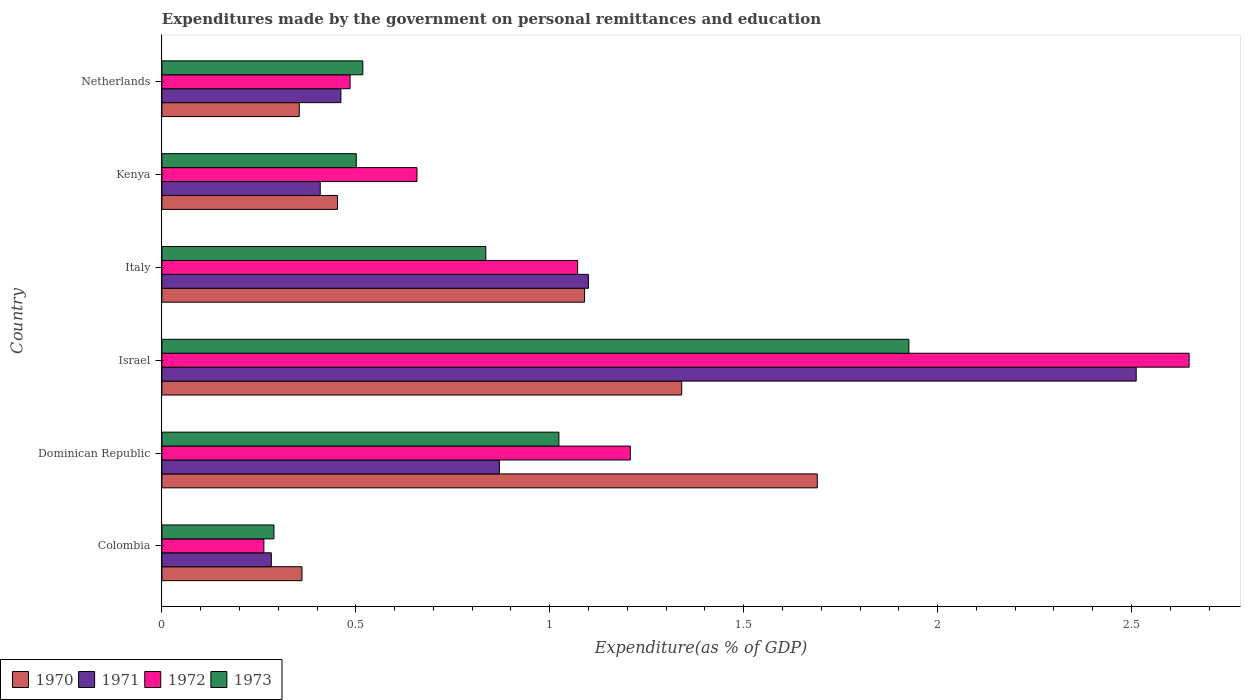How many different coloured bars are there?
Make the answer very short. 4. Are the number of bars per tick equal to the number of legend labels?
Keep it short and to the point. Yes. Are the number of bars on each tick of the Y-axis equal?
Provide a succinct answer. Yes. What is the label of the 2nd group of bars from the top?
Keep it short and to the point. Kenya. What is the expenditures made by the government on personal remittances and education in 1973 in Dominican Republic?
Give a very brief answer. 1.02. Across all countries, what is the maximum expenditures made by the government on personal remittances and education in 1972?
Offer a terse response. 2.65. Across all countries, what is the minimum expenditures made by the government on personal remittances and education in 1970?
Your answer should be compact. 0.35. In which country was the expenditures made by the government on personal remittances and education in 1972 minimum?
Provide a succinct answer. Colombia. What is the total expenditures made by the government on personal remittances and education in 1971 in the graph?
Ensure brevity in your answer.  5.63. What is the difference between the expenditures made by the government on personal remittances and education in 1971 in Dominican Republic and that in Netherlands?
Give a very brief answer. 0.41. What is the difference between the expenditures made by the government on personal remittances and education in 1972 in Dominican Republic and the expenditures made by the government on personal remittances and education in 1971 in Italy?
Ensure brevity in your answer.  0.11. What is the average expenditures made by the government on personal remittances and education in 1972 per country?
Provide a short and direct response. 1.06. What is the difference between the expenditures made by the government on personal remittances and education in 1973 and expenditures made by the government on personal remittances and education in 1970 in Israel?
Provide a succinct answer. 0.59. What is the ratio of the expenditures made by the government on personal remittances and education in 1973 in Dominican Republic to that in Kenya?
Offer a terse response. 2.04. Is the expenditures made by the government on personal remittances and education in 1971 in Colombia less than that in Italy?
Your response must be concise. Yes. Is the difference between the expenditures made by the government on personal remittances and education in 1973 in Italy and Netherlands greater than the difference between the expenditures made by the government on personal remittances and education in 1970 in Italy and Netherlands?
Offer a terse response. No. What is the difference between the highest and the second highest expenditures made by the government on personal remittances and education in 1971?
Your answer should be compact. 1.41. What is the difference between the highest and the lowest expenditures made by the government on personal remittances and education in 1971?
Your answer should be very brief. 2.23. In how many countries, is the expenditures made by the government on personal remittances and education in 1970 greater than the average expenditures made by the government on personal remittances and education in 1970 taken over all countries?
Offer a terse response. 3. What does the 3rd bar from the top in Colombia represents?
Offer a very short reply. 1971. What does the 1st bar from the bottom in Italy represents?
Ensure brevity in your answer.  1970. Is it the case that in every country, the sum of the expenditures made by the government on personal remittances and education in 1970 and expenditures made by the government on personal remittances and education in 1972 is greater than the expenditures made by the government on personal remittances and education in 1971?
Your answer should be compact. Yes. How many bars are there?
Keep it short and to the point. 24. Are all the bars in the graph horizontal?
Ensure brevity in your answer.  Yes. Are the values on the major ticks of X-axis written in scientific E-notation?
Your answer should be very brief. No. Does the graph contain grids?
Your answer should be very brief. No. Where does the legend appear in the graph?
Ensure brevity in your answer.  Bottom left. How many legend labels are there?
Make the answer very short. 4. How are the legend labels stacked?
Your answer should be very brief. Horizontal. What is the title of the graph?
Give a very brief answer. Expenditures made by the government on personal remittances and education. Does "1978" appear as one of the legend labels in the graph?
Ensure brevity in your answer.  No. What is the label or title of the X-axis?
Provide a succinct answer. Expenditure(as % of GDP). What is the Expenditure(as % of GDP) in 1970 in Colombia?
Keep it short and to the point. 0.36. What is the Expenditure(as % of GDP) of 1971 in Colombia?
Your answer should be compact. 0.28. What is the Expenditure(as % of GDP) in 1972 in Colombia?
Give a very brief answer. 0.26. What is the Expenditure(as % of GDP) of 1973 in Colombia?
Keep it short and to the point. 0.29. What is the Expenditure(as % of GDP) in 1970 in Dominican Republic?
Provide a short and direct response. 1.69. What is the Expenditure(as % of GDP) of 1971 in Dominican Republic?
Ensure brevity in your answer.  0.87. What is the Expenditure(as % of GDP) of 1972 in Dominican Republic?
Your response must be concise. 1.21. What is the Expenditure(as % of GDP) of 1973 in Dominican Republic?
Your response must be concise. 1.02. What is the Expenditure(as % of GDP) in 1970 in Israel?
Keep it short and to the point. 1.34. What is the Expenditure(as % of GDP) in 1971 in Israel?
Ensure brevity in your answer.  2.51. What is the Expenditure(as % of GDP) in 1972 in Israel?
Provide a succinct answer. 2.65. What is the Expenditure(as % of GDP) of 1973 in Israel?
Give a very brief answer. 1.93. What is the Expenditure(as % of GDP) of 1970 in Italy?
Give a very brief answer. 1.09. What is the Expenditure(as % of GDP) in 1971 in Italy?
Make the answer very short. 1.1. What is the Expenditure(as % of GDP) in 1972 in Italy?
Offer a terse response. 1.07. What is the Expenditure(as % of GDP) of 1973 in Italy?
Provide a succinct answer. 0.84. What is the Expenditure(as % of GDP) in 1970 in Kenya?
Provide a succinct answer. 0.45. What is the Expenditure(as % of GDP) in 1971 in Kenya?
Keep it short and to the point. 0.41. What is the Expenditure(as % of GDP) in 1972 in Kenya?
Provide a succinct answer. 0.66. What is the Expenditure(as % of GDP) in 1973 in Kenya?
Give a very brief answer. 0.5. What is the Expenditure(as % of GDP) of 1970 in Netherlands?
Keep it short and to the point. 0.35. What is the Expenditure(as % of GDP) in 1971 in Netherlands?
Give a very brief answer. 0.46. What is the Expenditure(as % of GDP) of 1972 in Netherlands?
Your answer should be compact. 0.49. What is the Expenditure(as % of GDP) of 1973 in Netherlands?
Your response must be concise. 0.52. Across all countries, what is the maximum Expenditure(as % of GDP) in 1970?
Your answer should be compact. 1.69. Across all countries, what is the maximum Expenditure(as % of GDP) in 1971?
Provide a succinct answer. 2.51. Across all countries, what is the maximum Expenditure(as % of GDP) of 1972?
Provide a short and direct response. 2.65. Across all countries, what is the maximum Expenditure(as % of GDP) of 1973?
Your response must be concise. 1.93. Across all countries, what is the minimum Expenditure(as % of GDP) of 1970?
Ensure brevity in your answer.  0.35. Across all countries, what is the minimum Expenditure(as % of GDP) in 1971?
Offer a very short reply. 0.28. Across all countries, what is the minimum Expenditure(as % of GDP) in 1972?
Give a very brief answer. 0.26. Across all countries, what is the minimum Expenditure(as % of GDP) of 1973?
Keep it short and to the point. 0.29. What is the total Expenditure(as % of GDP) in 1970 in the graph?
Provide a succinct answer. 5.29. What is the total Expenditure(as % of GDP) in 1971 in the graph?
Offer a terse response. 5.63. What is the total Expenditure(as % of GDP) in 1972 in the graph?
Your response must be concise. 6.33. What is the total Expenditure(as % of GDP) in 1973 in the graph?
Give a very brief answer. 5.09. What is the difference between the Expenditure(as % of GDP) in 1970 in Colombia and that in Dominican Republic?
Your answer should be very brief. -1.33. What is the difference between the Expenditure(as % of GDP) in 1971 in Colombia and that in Dominican Republic?
Give a very brief answer. -0.59. What is the difference between the Expenditure(as % of GDP) of 1972 in Colombia and that in Dominican Republic?
Offer a terse response. -0.94. What is the difference between the Expenditure(as % of GDP) of 1973 in Colombia and that in Dominican Republic?
Your answer should be compact. -0.73. What is the difference between the Expenditure(as % of GDP) of 1970 in Colombia and that in Israel?
Your response must be concise. -0.98. What is the difference between the Expenditure(as % of GDP) in 1971 in Colombia and that in Israel?
Provide a succinct answer. -2.23. What is the difference between the Expenditure(as % of GDP) in 1972 in Colombia and that in Israel?
Your answer should be compact. -2.39. What is the difference between the Expenditure(as % of GDP) in 1973 in Colombia and that in Israel?
Your answer should be very brief. -1.64. What is the difference between the Expenditure(as % of GDP) of 1970 in Colombia and that in Italy?
Offer a terse response. -0.73. What is the difference between the Expenditure(as % of GDP) in 1971 in Colombia and that in Italy?
Make the answer very short. -0.82. What is the difference between the Expenditure(as % of GDP) of 1972 in Colombia and that in Italy?
Offer a very short reply. -0.81. What is the difference between the Expenditure(as % of GDP) of 1973 in Colombia and that in Italy?
Your answer should be very brief. -0.55. What is the difference between the Expenditure(as % of GDP) of 1970 in Colombia and that in Kenya?
Keep it short and to the point. -0.09. What is the difference between the Expenditure(as % of GDP) in 1971 in Colombia and that in Kenya?
Ensure brevity in your answer.  -0.13. What is the difference between the Expenditure(as % of GDP) of 1972 in Colombia and that in Kenya?
Offer a terse response. -0.39. What is the difference between the Expenditure(as % of GDP) in 1973 in Colombia and that in Kenya?
Offer a terse response. -0.21. What is the difference between the Expenditure(as % of GDP) in 1970 in Colombia and that in Netherlands?
Your response must be concise. 0.01. What is the difference between the Expenditure(as % of GDP) in 1971 in Colombia and that in Netherlands?
Keep it short and to the point. -0.18. What is the difference between the Expenditure(as % of GDP) in 1972 in Colombia and that in Netherlands?
Ensure brevity in your answer.  -0.22. What is the difference between the Expenditure(as % of GDP) of 1973 in Colombia and that in Netherlands?
Keep it short and to the point. -0.23. What is the difference between the Expenditure(as % of GDP) of 1970 in Dominican Republic and that in Israel?
Offer a terse response. 0.35. What is the difference between the Expenditure(as % of GDP) of 1971 in Dominican Republic and that in Israel?
Keep it short and to the point. -1.64. What is the difference between the Expenditure(as % of GDP) of 1972 in Dominican Republic and that in Israel?
Make the answer very short. -1.44. What is the difference between the Expenditure(as % of GDP) of 1973 in Dominican Republic and that in Israel?
Ensure brevity in your answer.  -0.9. What is the difference between the Expenditure(as % of GDP) in 1970 in Dominican Republic and that in Italy?
Your answer should be very brief. 0.6. What is the difference between the Expenditure(as % of GDP) of 1971 in Dominican Republic and that in Italy?
Give a very brief answer. -0.23. What is the difference between the Expenditure(as % of GDP) of 1972 in Dominican Republic and that in Italy?
Offer a very short reply. 0.14. What is the difference between the Expenditure(as % of GDP) of 1973 in Dominican Republic and that in Italy?
Provide a succinct answer. 0.19. What is the difference between the Expenditure(as % of GDP) in 1970 in Dominican Republic and that in Kenya?
Offer a very short reply. 1.24. What is the difference between the Expenditure(as % of GDP) in 1971 in Dominican Republic and that in Kenya?
Provide a succinct answer. 0.46. What is the difference between the Expenditure(as % of GDP) of 1972 in Dominican Republic and that in Kenya?
Your answer should be compact. 0.55. What is the difference between the Expenditure(as % of GDP) in 1973 in Dominican Republic and that in Kenya?
Keep it short and to the point. 0.52. What is the difference between the Expenditure(as % of GDP) of 1970 in Dominican Republic and that in Netherlands?
Provide a short and direct response. 1.34. What is the difference between the Expenditure(as % of GDP) in 1971 in Dominican Republic and that in Netherlands?
Make the answer very short. 0.41. What is the difference between the Expenditure(as % of GDP) of 1972 in Dominican Republic and that in Netherlands?
Offer a very short reply. 0.72. What is the difference between the Expenditure(as % of GDP) in 1973 in Dominican Republic and that in Netherlands?
Your answer should be compact. 0.51. What is the difference between the Expenditure(as % of GDP) in 1970 in Israel and that in Italy?
Make the answer very short. 0.25. What is the difference between the Expenditure(as % of GDP) of 1971 in Israel and that in Italy?
Provide a short and direct response. 1.41. What is the difference between the Expenditure(as % of GDP) in 1972 in Israel and that in Italy?
Provide a succinct answer. 1.58. What is the difference between the Expenditure(as % of GDP) of 1970 in Israel and that in Kenya?
Give a very brief answer. 0.89. What is the difference between the Expenditure(as % of GDP) in 1971 in Israel and that in Kenya?
Your answer should be very brief. 2.1. What is the difference between the Expenditure(as % of GDP) of 1972 in Israel and that in Kenya?
Your response must be concise. 1.99. What is the difference between the Expenditure(as % of GDP) in 1973 in Israel and that in Kenya?
Provide a short and direct response. 1.42. What is the difference between the Expenditure(as % of GDP) of 1970 in Israel and that in Netherlands?
Provide a succinct answer. 0.99. What is the difference between the Expenditure(as % of GDP) in 1971 in Israel and that in Netherlands?
Make the answer very short. 2.05. What is the difference between the Expenditure(as % of GDP) in 1972 in Israel and that in Netherlands?
Your answer should be very brief. 2.16. What is the difference between the Expenditure(as % of GDP) of 1973 in Israel and that in Netherlands?
Ensure brevity in your answer.  1.41. What is the difference between the Expenditure(as % of GDP) in 1970 in Italy and that in Kenya?
Give a very brief answer. 0.64. What is the difference between the Expenditure(as % of GDP) in 1971 in Italy and that in Kenya?
Provide a short and direct response. 0.69. What is the difference between the Expenditure(as % of GDP) of 1972 in Italy and that in Kenya?
Offer a very short reply. 0.41. What is the difference between the Expenditure(as % of GDP) of 1973 in Italy and that in Kenya?
Offer a terse response. 0.33. What is the difference between the Expenditure(as % of GDP) in 1970 in Italy and that in Netherlands?
Provide a succinct answer. 0.74. What is the difference between the Expenditure(as % of GDP) in 1971 in Italy and that in Netherlands?
Your response must be concise. 0.64. What is the difference between the Expenditure(as % of GDP) of 1972 in Italy and that in Netherlands?
Provide a succinct answer. 0.59. What is the difference between the Expenditure(as % of GDP) of 1973 in Italy and that in Netherlands?
Offer a terse response. 0.32. What is the difference between the Expenditure(as % of GDP) of 1970 in Kenya and that in Netherlands?
Offer a terse response. 0.1. What is the difference between the Expenditure(as % of GDP) in 1971 in Kenya and that in Netherlands?
Provide a succinct answer. -0.05. What is the difference between the Expenditure(as % of GDP) in 1972 in Kenya and that in Netherlands?
Keep it short and to the point. 0.17. What is the difference between the Expenditure(as % of GDP) of 1973 in Kenya and that in Netherlands?
Provide a short and direct response. -0.02. What is the difference between the Expenditure(as % of GDP) of 1970 in Colombia and the Expenditure(as % of GDP) of 1971 in Dominican Republic?
Your answer should be very brief. -0.51. What is the difference between the Expenditure(as % of GDP) of 1970 in Colombia and the Expenditure(as % of GDP) of 1972 in Dominican Republic?
Give a very brief answer. -0.85. What is the difference between the Expenditure(as % of GDP) of 1970 in Colombia and the Expenditure(as % of GDP) of 1973 in Dominican Republic?
Your answer should be very brief. -0.66. What is the difference between the Expenditure(as % of GDP) in 1971 in Colombia and the Expenditure(as % of GDP) in 1972 in Dominican Republic?
Offer a terse response. -0.93. What is the difference between the Expenditure(as % of GDP) in 1971 in Colombia and the Expenditure(as % of GDP) in 1973 in Dominican Republic?
Your answer should be compact. -0.74. What is the difference between the Expenditure(as % of GDP) in 1972 in Colombia and the Expenditure(as % of GDP) in 1973 in Dominican Republic?
Make the answer very short. -0.76. What is the difference between the Expenditure(as % of GDP) of 1970 in Colombia and the Expenditure(as % of GDP) of 1971 in Israel?
Provide a short and direct response. -2.15. What is the difference between the Expenditure(as % of GDP) of 1970 in Colombia and the Expenditure(as % of GDP) of 1972 in Israel?
Keep it short and to the point. -2.29. What is the difference between the Expenditure(as % of GDP) in 1970 in Colombia and the Expenditure(as % of GDP) in 1973 in Israel?
Provide a short and direct response. -1.56. What is the difference between the Expenditure(as % of GDP) of 1971 in Colombia and the Expenditure(as % of GDP) of 1972 in Israel?
Your response must be concise. -2.37. What is the difference between the Expenditure(as % of GDP) in 1971 in Colombia and the Expenditure(as % of GDP) in 1973 in Israel?
Ensure brevity in your answer.  -1.64. What is the difference between the Expenditure(as % of GDP) of 1972 in Colombia and the Expenditure(as % of GDP) of 1973 in Israel?
Keep it short and to the point. -1.66. What is the difference between the Expenditure(as % of GDP) of 1970 in Colombia and the Expenditure(as % of GDP) of 1971 in Italy?
Your answer should be very brief. -0.74. What is the difference between the Expenditure(as % of GDP) in 1970 in Colombia and the Expenditure(as % of GDP) in 1972 in Italy?
Make the answer very short. -0.71. What is the difference between the Expenditure(as % of GDP) of 1970 in Colombia and the Expenditure(as % of GDP) of 1973 in Italy?
Offer a terse response. -0.47. What is the difference between the Expenditure(as % of GDP) of 1971 in Colombia and the Expenditure(as % of GDP) of 1972 in Italy?
Your response must be concise. -0.79. What is the difference between the Expenditure(as % of GDP) in 1971 in Colombia and the Expenditure(as % of GDP) in 1973 in Italy?
Ensure brevity in your answer.  -0.55. What is the difference between the Expenditure(as % of GDP) in 1972 in Colombia and the Expenditure(as % of GDP) in 1973 in Italy?
Your answer should be compact. -0.57. What is the difference between the Expenditure(as % of GDP) of 1970 in Colombia and the Expenditure(as % of GDP) of 1971 in Kenya?
Your answer should be very brief. -0.05. What is the difference between the Expenditure(as % of GDP) in 1970 in Colombia and the Expenditure(as % of GDP) in 1972 in Kenya?
Offer a terse response. -0.3. What is the difference between the Expenditure(as % of GDP) of 1970 in Colombia and the Expenditure(as % of GDP) of 1973 in Kenya?
Your answer should be very brief. -0.14. What is the difference between the Expenditure(as % of GDP) of 1971 in Colombia and the Expenditure(as % of GDP) of 1972 in Kenya?
Offer a terse response. -0.38. What is the difference between the Expenditure(as % of GDP) of 1971 in Colombia and the Expenditure(as % of GDP) of 1973 in Kenya?
Offer a very short reply. -0.22. What is the difference between the Expenditure(as % of GDP) in 1972 in Colombia and the Expenditure(as % of GDP) in 1973 in Kenya?
Provide a short and direct response. -0.24. What is the difference between the Expenditure(as % of GDP) in 1970 in Colombia and the Expenditure(as % of GDP) in 1971 in Netherlands?
Your answer should be compact. -0.1. What is the difference between the Expenditure(as % of GDP) of 1970 in Colombia and the Expenditure(as % of GDP) of 1972 in Netherlands?
Your answer should be very brief. -0.12. What is the difference between the Expenditure(as % of GDP) of 1970 in Colombia and the Expenditure(as % of GDP) of 1973 in Netherlands?
Make the answer very short. -0.16. What is the difference between the Expenditure(as % of GDP) in 1971 in Colombia and the Expenditure(as % of GDP) in 1972 in Netherlands?
Give a very brief answer. -0.2. What is the difference between the Expenditure(as % of GDP) of 1971 in Colombia and the Expenditure(as % of GDP) of 1973 in Netherlands?
Provide a succinct answer. -0.24. What is the difference between the Expenditure(as % of GDP) of 1972 in Colombia and the Expenditure(as % of GDP) of 1973 in Netherlands?
Your response must be concise. -0.26. What is the difference between the Expenditure(as % of GDP) in 1970 in Dominican Republic and the Expenditure(as % of GDP) in 1971 in Israel?
Offer a terse response. -0.82. What is the difference between the Expenditure(as % of GDP) in 1970 in Dominican Republic and the Expenditure(as % of GDP) in 1972 in Israel?
Offer a very short reply. -0.96. What is the difference between the Expenditure(as % of GDP) in 1970 in Dominican Republic and the Expenditure(as % of GDP) in 1973 in Israel?
Your answer should be very brief. -0.24. What is the difference between the Expenditure(as % of GDP) of 1971 in Dominican Republic and the Expenditure(as % of GDP) of 1972 in Israel?
Ensure brevity in your answer.  -1.78. What is the difference between the Expenditure(as % of GDP) in 1971 in Dominican Republic and the Expenditure(as % of GDP) in 1973 in Israel?
Keep it short and to the point. -1.06. What is the difference between the Expenditure(as % of GDP) of 1972 in Dominican Republic and the Expenditure(as % of GDP) of 1973 in Israel?
Offer a terse response. -0.72. What is the difference between the Expenditure(as % of GDP) in 1970 in Dominican Republic and the Expenditure(as % of GDP) in 1971 in Italy?
Give a very brief answer. 0.59. What is the difference between the Expenditure(as % of GDP) in 1970 in Dominican Republic and the Expenditure(as % of GDP) in 1972 in Italy?
Provide a succinct answer. 0.62. What is the difference between the Expenditure(as % of GDP) in 1970 in Dominican Republic and the Expenditure(as % of GDP) in 1973 in Italy?
Provide a short and direct response. 0.85. What is the difference between the Expenditure(as % of GDP) of 1971 in Dominican Republic and the Expenditure(as % of GDP) of 1972 in Italy?
Provide a succinct answer. -0.2. What is the difference between the Expenditure(as % of GDP) of 1971 in Dominican Republic and the Expenditure(as % of GDP) of 1973 in Italy?
Keep it short and to the point. 0.04. What is the difference between the Expenditure(as % of GDP) of 1972 in Dominican Republic and the Expenditure(as % of GDP) of 1973 in Italy?
Keep it short and to the point. 0.37. What is the difference between the Expenditure(as % of GDP) of 1970 in Dominican Republic and the Expenditure(as % of GDP) of 1971 in Kenya?
Keep it short and to the point. 1.28. What is the difference between the Expenditure(as % of GDP) in 1970 in Dominican Republic and the Expenditure(as % of GDP) in 1972 in Kenya?
Your answer should be compact. 1.03. What is the difference between the Expenditure(as % of GDP) in 1970 in Dominican Republic and the Expenditure(as % of GDP) in 1973 in Kenya?
Your answer should be very brief. 1.19. What is the difference between the Expenditure(as % of GDP) of 1971 in Dominican Republic and the Expenditure(as % of GDP) of 1972 in Kenya?
Provide a short and direct response. 0.21. What is the difference between the Expenditure(as % of GDP) in 1971 in Dominican Republic and the Expenditure(as % of GDP) in 1973 in Kenya?
Keep it short and to the point. 0.37. What is the difference between the Expenditure(as % of GDP) in 1972 in Dominican Republic and the Expenditure(as % of GDP) in 1973 in Kenya?
Offer a terse response. 0.71. What is the difference between the Expenditure(as % of GDP) in 1970 in Dominican Republic and the Expenditure(as % of GDP) in 1971 in Netherlands?
Provide a short and direct response. 1.23. What is the difference between the Expenditure(as % of GDP) in 1970 in Dominican Republic and the Expenditure(as % of GDP) in 1972 in Netherlands?
Make the answer very short. 1.2. What is the difference between the Expenditure(as % of GDP) of 1970 in Dominican Republic and the Expenditure(as % of GDP) of 1973 in Netherlands?
Give a very brief answer. 1.17. What is the difference between the Expenditure(as % of GDP) of 1971 in Dominican Republic and the Expenditure(as % of GDP) of 1972 in Netherlands?
Offer a very short reply. 0.39. What is the difference between the Expenditure(as % of GDP) in 1971 in Dominican Republic and the Expenditure(as % of GDP) in 1973 in Netherlands?
Make the answer very short. 0.35. What is the difference between the Expenditure(as % of GDP) in 1972 in Dominican Republic and the Expenditure(as % of GDP) in 1973 in Netherlands?
Keep it short and to the point. 0.69. What is the difference between the Expenditure(as % of GDP) of 1970 in Israel and the Expenditure(as % of GDP) of 1971 in Italy?
Your answer should be very brief. 0.24. What is the difference between the Expenditure(as % of GDP) of 1970 in Israel and the Expenditure(as % of GDP) of 1972 in Italy?
Provide a succinct answer. 0.27. What is the difference between the Expenditure(as % of GDP) of 1970 in Israel and the Expenditure(as % of GDP) of 1973 in Italy?
Give a very brief answer. 0.51. What is the difference between the Expenditure(as % of GDP) of 1971 in Israel and the Expenditure(as % of GDP) of 1972 in Italy?
Provide a succinct answer. 1.44. What is the difference between the Expenditure(as % of GDP) in 1971 in Israel and the Expenditure(as % of GDP) in 1973 in Italy?
Your answer should be compact. 1.68. What is the difference between the Expenditure(as % of GDP) of 1972 in Israel and the Expenditure(as % of GDP) of 1973 in Italy?
Provide a succinct answer. 1.81. What is the difference between the Expenditure(as % of GDP) in 1970 in Israel and the Expenditure(as % of GDP) in 1971 in Kenya?
Your response must be concise. 0.93. What is the difference between the Expenditure(as % of GDP) in 1970 in Israel and the Expenditure(as % of GDP) in 1972 in Kenya?
Your answer should be compact. 0.68. What is the difference between the Expenditure(as % of GDP) of 1970 in Israel and the Expenditure(as % of GDP) of 1973 in Kenya?
Make the answer very short. 0.84. What is the difference between the Expenditure(as % of GDP) in 1971 in Israel and the Expenditure(as % of GDP) in 1972 in Kenya?
Provide a succinct answer. 1.85. What is the difference between the Expenditure(as % of GDP) in 1971 in Israel and the Expenditure(as % of GDP) in 1973 in Kenya?
Your answer should be very brief. 2.01. What is the difference between the Expenditure(as % of GDP) in 1972 in Israel and the Expenditure(as % of GDP) in 1973 in Kenya?
Provide a succinct answer. 2.15. What is the difference between the Expenditure(as % of GDP) of 1970 in Israel and the Expenditure(as % of GDP) of 1971 in Netherlands?
Offer a very short reply. 0.88. What is the difference between the Expenditure(as % of GDP) in 1970 in Israel and the Expenditure(as % of GDP) in 1972 in Netherlands?
Your answer should be compact. 0.85. What is the difference between the Expenditure(as % of GDP) in 1970 in Israel and the Expenditure(as % of GDP) in 1973 in Netherlands?
Provide a succinct answer. 0.82. What is the difference between the Expenditure(as % of GDP) in 1971 in Israel and the Expenditure(as % of GDP) in 1972 in Netherlands?
Your response must be concise. 2.03. What is the difference between the Expenditure(as % of GDP) in 1971 in Israel and the Expenditure(as % of GDP) in 1973 in Netherlands?
Your response must be concise. 1.99. What is the difference between the Expenditure(as % of GDP) in 1972 in Israel and the Expenditure(as % of GDP) in 1973 in Netherlands?
Your answer should be very brief. 2.13. What is the difference between the Expenditure(as % of GDP) in 1970 in Italy and the Expenditure(as % of GDP) in 1971 in Kenya?
Your answer should be very brief. 0.68. What is the difference between the Expenditure(as % of GDP) in 1970 in Italy and the Expenditure(as % of GDP) in 1972 in Kenya?
Keep it short and to the point. 0.43. What is the difference between the Expenditure(as % of GDP) in 1970 in Italy and the Expenditure(as % of GDP) in 1973 in Kenya?
Provide a succinct answer. 0.59. What is the difference between the Expenditure(as % of GDP) of 1971 in Italy and the Expenditure(as % of GDP) of 1972 in Kenya?
Your answer should be compact. 0.44. What is the difference between the Expenditure(as % of GDP) of 1971 in Italy and the Expenditure(as % of GDP) of 1973 in Kenya?
Offer a terse response. 0.6. What is the difference between the Expenditure(as % of GDP) of 1972 in Italy and the Expenditure(as % of GDP) of 1973 in Kenya?
Your answer should be compact. 0.57. What is the difference between the Expenditure(as % of GDP) of 1970 in Italy and the Expenditure(as % of GDP) of 1971 in Netherlands?
Offer a terse response. 0.63. What is the difference between the Expenditure(as % of GDP) of 1970 in Italy and the Expenditure(as % of GDP) of 1972 in Netherlands?
Your answer should be very brief. 0.6. What is the difference between the Expenditure(as % of GDP) in 1970 in Italy and the Expenditure(as % of GDP) in 1973 in Netherlands?
Give a very brief answer. 0.57. What is the difference between the Expenditure(as % of GDP) in 1971 in Italy and the Expenditure(as % of GDP) in 1972 in Netherlands?
Your answer should be very brief. 0.61. What is the difference between the Expenditure(as % of GDP) in 1971 in Italy and the Expenditure(as % of GDP) in 1973 in Netherlands?
Give a very brief answer. 0.58. What is the difference between the Expenditure(as % of GDP) of 1972 in Italy and the Expenditure(as % of GDP) of 1973 in Netherlands?
Offer a very short reply. 0.55. What is the difference between the Expenditure(as % of GDP) in 1970 in Kenya and the Expenditure(as % of GDP) in 1971 in Netherlands?
Your answer should be very brief. -0.01. What is the difference between the Expenditure(as % of GDP) in 1970 in Kenya and the Expenditure(as % of GDP) in 1972 in Netherlands?
Your answer should be compact. -0.03. What is the difference between the Expenditure(as % of GDP) of 1970 in Kenya and the Expenditure(as % of GDP) of 1973 in Netherlands?
Make the answer very short. -0.07. What is the difference between the Expenditure(as % of GDP) in 1971 in Kenya and the Expenditure(as % of GDP) in 1972 in Netherlands?
Make the answer very short. -0.08. What is the difference between the Expenditure(as % of GDP) of 1971 in Kenya and the Expenditure(as % of GDP) of 1973 in Netherlands?
Offer a very short reply. -0.11. What is the difference between the Expenditure(as % of GDP) in 1972 in Kenya and the Expenditure(as % of GDP) in 1973 in Netherlands?
Provide a short and direct response. 0.14. What is the average Expenditure(as % of GDP) of 1970 per country?
Give a very brief answer. 0.88. What is the average Expenditure(as % of GDP) of 1971 per country?
Keep it short and to the point. 0.94. What is the average Expenditure(as % of GDP) of 1972 per country?
Your answer should be compact. 1.06. What is the average Expenditure(as % of GDP) of 1973 per country?
Ensure brevity in your answer.  0.85. What is the difference between the Expenditure(as % of GDP) in 1970 and Expenditure(as % of GDP) in 1971 in Colombia?
Provide a succinct answer. 0.08. What is the difference between the Expenditure(as % of GDP) of 1970 and Expenditure(as % of GDP) of 1972 in Colombia?
Provide a short and direct response. 0.1. What is the difference between the Expenditure(as % of GDP) of 1970 and Expenditure(as % of GDP) of 1973 in Colombia?
Keep it short and to the point. 0.07. What is the difference between the Expenditure(as % of GDP) of 1971 and Expenditure(as % of GDP) of 1972 in Colombia?
Offer a terse response. 0.02. What is the difference between the Expenditure(as % of GDP) of 1971 and Expenditure(as % of GDP) of 1973 in Colombia?
Provide a short and direct response. -0.01. What is the difference between the Expenditure(as % of GDP) of 1972 and Expenditure(as % of GDP) of 1973 in Colombia?
Provide a short and direct response. -0.03. What is the difference between the Expenditure(as % of GDP) of 1970 and Expenditure(as % of GDP) of 1971 in Dominican Republic?
Your response must be concise. 0.82. What is the difference between the Expenditure(as % of GDP) of 1970 and Expenditure(as % of GDP) of 1972 in Dominican Republic?
Your response must be concise. 0.48. What is the difference between the Expenditure(as % of GDP) in 1970 and Expenditure(as % of GDP) in 1973 in Dominican Republic?
Your response must be concise. 0.67. What is the difference between the Expenditure(as % of GDP) of 1971 and Expenditure(as % of GDP) of 1972 in Dominican Republic?
Keep it short and to the point. -0.34. What is the difference between the Expenditure(as % of GDP) in 1971 and Expenditure(as % of GDP) in 1973 in Dominican Republic?
Provide a succinct answer. -0.15. What is the difference between the Expenditure(as % of GDP) in 1972 and Expenditure(as % of GDP) in 1973 in Dominican Republic?
Keep it short and to the point. 0.18. What is the difference between the Expenditure(as % of GDP) in 1970 and Expenditure(as % of GDP) in 1971 in Israel?
Make the answer very short. -1.17. What is the difference between the Expenditure(as % of GDP) in 1970 and Expenditure(as % of GDP) in 1972 in Israel?
Your answer should be very brief. -1.31. What is the difference between the Expenditure(as % of GDP) of 1970 and Expenditure(as % of GDP) of 1973 in Israel?
Offer a terse response. -0.59. What is the difference between the Expenditure(as % of GDP) of 1971 and Expenditure(as % of GDP) of 1972 in Israel?
Provide a short and direct response. -0.14. What is the difference between the Expenditure(as % of GDP) of 1971 and Expenditure(as % of GDP) of 1973 in Israel?
Offer a very short reply. 0.59. What is the difference between the Expenditure(as % of GDP) of 1972 and Expenditure(as % of GDP) of 1973 in Israel?
Your answer should be very brief. 0.72. What is the difference between the Expenditure(as % of GDP) in 1970 and Expenditure(as % of GDP) in 1971 in Italy?
Offer a terse response. -0.01. What is the difference between the Expenditure(as % of GDP) of 1970 and Expenditure(as % of GDP) of 1972 in Italy?
Your answer should be compact. 0.02. What is the difference between the Expenditure(as % of GDP) of 1970 and Expenditure(as % of GDP) of 1973 in Italy?
Your answer should be compact. 0.25. What is the difference between the Expenditure(as % of GDP) of 1971 and Expenditure(as % of GDP) of 1972 in Italy?
Your answer should be compact. 0.03. What is the difference between the Expenditure(as % of GDP) of 1971 and Expenditure(as % of GDP) of 1973 in Italy?
Keep it short and to the point. 0.26. What is the difference between the Expenditure(as % of GDP) in 1972 and Expenditure(as % of GDP) in 1973 in Italy?
Give a very brief answer. 0.24. What is the difference between the Expenditure(as % of GDP) in 1970 and Expenditure(as % of GDP) in 1971 in Kenya?
Provide a succinct answer. 0.04. What is the difference between the Expenditure(as % of GDP) in 1970 and Expenditure(as % of GDP) in 1972 in Kenya?
Give a very brief answer. -0.2. What is the difference between the Expenditure(as % of GDP) of 1970 and Expenditure(as % of GDP) of 1973 in Kenya?
Give a very brief answer. -0.05. What is the difference between the Expenditure(as % of GDP) in 1971 and Expenditure(as % of GDP) in 1972 in Kenya?
Offer a very short reply. -0.25. What is the difference between the Expenditure(as % of GDP) in 1971 and Expenditure(as % of GDP) in 1973 in Kenya?
Offer a terse response. -0.09. What is the difference between the Expenditure(as % of GDP) of 1972 and Expenditure(as % of GDP) of 1973 in Kenya?
Keep it short and to the point. 0.16. What is the difference between the Expenditure(as % of GDP) in 1970 and Expenditure(as % of GDP) in 1971 in Netherlands?
Your answer should be compact. -0.11. What is the difference between the Expenditure(as % of GDP) in 1970 and Expenditure(as % of GDP) in 1972 in Netherlands?
Keep it short and to the point. -0.13. What is the difference between the Expenditure(as % of GDP) of 1970 and Expenditure(as % of GDP) of 1973 in Netherlands?
Give a very brief answer. -0.16. What is the difference between the Expenditure(as % of GDP) in 1971 and Expenditure(as % of GDP) in 1972 in Netherlands?
Your answer should be very brief. -0.02. What is the difference between the Expenditure(as % of GDP) of 1971 and Expenditure(as % of GDP) of 1973 in Netherlands?
Offer a terse response. -0.06. What is the difference between the Expenditure(as % of GDP) of 1972 and Expenditure(as % of GDP) of 1973 in Netherlands?
Provide a succinct answer. -0.03. What is the ratio of the Expenditure(as % of GDP) in 1970 in Colombia to that in Dominican Republic?
Provide a succinct answer. 0.21. What is the ratio of the Expenditure(as % of GDP) in 1971 in Colombia to that in Dominican Republic?
Your answer should be very brief. 0.32. What is the ratio of the Expenditure(as % of GDP) in 1972 in Colombia to that in Dominican Republic?
Make the answer very short. 0.22. What is the ratio of the Expenditure(as % of GDP) in 1973 in Colombia to that in Dominican Republic?
Provide a short and direct response. 0.28. What is the ratio of the Expenditure(as % of GDP) in 1970 in Colombia to that in Israel?
Ensure brevity in your answer.  0.27. What is the ratio of the Expenditure(as % of GDP) of 1971 in Colombia to that in Israel?
Your answer should be very brief. 0.11. What is the ratio of the Expenditure(as % of GDP) of 1972 in Colombia to that in Israel?
Your answer should be very brief. 0.1. What is the ratio of the Expenditure(as % of GDP) of 1973 in Colombia to that in Israel?
Give a very brief answer. 0.15. What is the ratio of the Expenditure(as % of GDP) of 1970 in Colombia to that in Italy?
Offer a very short reply. 0.33. What is the ratio of the Expenditure(as % of GDP) in 1971 in Colombia to that in Italy?
Your response must be concise. 0.26. What is the ratio of the Expenditure(as % of GDP) in 1972 in Colombia to that in Italy?
Your answer should be very brief. 0.25. What is the ratio of the Expenditure(as % of GDP) of 1973 in Colombia to that in Italy?
Provide a short and direct response. 0.35. What is the ratio of the Expenditure(as % of GDP) of 1970 in Colombia to that in Kenya?
Provide a short and direct response. 0.8. What is the ratio of the Expenditure(as % of GDP) of 1971 in Colombia to that in Kenya?
Offer a terse response. 0.69. What is the ratio of the Expenditure(as % of GDP) in 1972 in Colombia to that in Kenya?
Provide a succinct answer. 0.4. What is the ratio of the Expenditure(as % of GDP) of 1973 in Colombia to that in Kenya?
Offer a very short reply. 0.58. What is the ratio of the Expenditure(as % of GDP) in 1971 in Colombia to that in Netherlands?
Make the answer very short. 0.61. What is the ratio of the Expenditure(as % of GDP) of 1972 in Colombia to that in Netherlands?
Provide a short and direct response. 0.54. What is the ratio of the Expenditure(as % of GDP) in 1973 in Colombia to that in Netherlands?
Provide a succinct answer. 0.56. What is the ratio of the Expenditure(as % of GDP) in 1970 in Dominican Republic to that in Israel?
Your answer should be very brief. 1.26. What is the ratio of the Expenditure(as % of GDP) in 1971 in Dominican Republic to that in Israel?
Give a very brief answer. 0.35. What is the ratio of the Expenditure(as % of GDP) of 1972 in Dominican Republic to that in Israel?
Give a very brief answer. 0.46. What is the ratio of the Expenditure(as % of GDP) in 1973 in Dominican Republic to that in Israel?
Offer a terse response. 0.53. What is the ratio of the Expenditure(as % of GDP) in 1970 in Dominican Republic to that in Italy?
Your answer should be very brief. 1.55. What is the ratio of the Expenditure(as % of GDP) in 1971 in Dominican Republic to that in Italy?
Offer a terse response. 0.79. What is the ratio of the Expenditure(as % of GDP) of 1972 in Dominican Republic to that in Italy?
Keep it short and to the point. 1.13. What is the ratio of the Expenditure(as % of GDP) of 1973 in Dominican Republic to that in Italy?
Your answer should be very brief. 1.23. What is the ratio of the Expenditure(as % of GDP) in 1970 in Dominican Republic to that in Kenya?
Your response must be concise. 3.73. What is the ratio of the Expenditure(as % of GDP) in 1971 in Dominican Republic to that in Kenya?
Offer a very short reply. 2.13. What is the ratio of the Expenditure(as % of GDP) of 1972 in Dominican Republic to that in Kenya?
Give a very brief answer. 1.84. What is the ratio of the Expenditure(as % of GDP) in 1973 in Dominican Republic to that in Kenya?
Offer a terse response. 2.04. What is the ratio of the Expenditure(as % of GDP) in 1970 in Dominican Republic to that in Netherlands?
Your answer should be compact. 4.77. What is the ratio of the Expenditure(as % of GDP) of 1971 in Dominican Republic to that in Netherlands?
Keep it short and to the point. 1.89. What is the ratio of the Expenditure(as % of GDP) of 1972 in Dominican Republic to that in Netherlands?
Provide a succinct answer. 2.49. What is the ratio of the Expenditure(as % of GDP) of 1973 in Dominican Republic to that in Netherlands?
Offer a terse response. 1.98. What is the ratio of the Expenditure(as % of GDP) in 1970 in Israel to that in Italy?
Provide a short and direct response. 1.23. What is the ratio of the Expenditure(as % of GDP) of 1971 in Israel to that in Italy?
Keep it short and to the point. 2.28. What is the ratio of the Expenditure(as % of GDP) in 1972 in Israel to that in Italy?
Give a very brief answer. 2.47. What is the ratio of the Expenditure(as % of GDP) of 1973 in Israel to that in Italy?
Your answer should be very brief. 2.31. What is the ratio of the Expenditure(as % of GDP) of 1970 in Israel to that in Kenya?
Your answer should be very brief. 2.96. What is the ratio of the Expenditure(as % of GDP) in 1971 in Israel to that in Kenya?
Give a very brief answer. 6.15. What is the ratio of the Expenditure(as % of GDP) of 1972 in Israel to that in Kenya?
Give a very brief answer. 4.03. What is the ratio of the Expenditure(as % of GDP) of 1973 in Israel to that in Kenya?
Ensure brevity in your answer.  3.84. What is the ratio of the Expenditure(as % of GDP) of 1970 in Israel to that in Netherlands?
Ensure brevity in your answer.  3.78. What is the ratio of the Expenditure(as % of GDP) in 1971 in Israel to that in Netherlands?
Your response must be concise. 5.44. What is the ratio of the Expenditure(as % of GDP) of 1972 in Israel to that in Netherlands?
Offer a terse response. 5.46. What is the ratio of the Expenditure(as % of GDP) in 1973 in Israel to that in Netherlands?
Offer a very short reply. 3.72. What is the ratio of the Expenditure(as % of GDP) in 1970 in Italy to that in Kenya?
Give a very brief answer. 2.41. What is the ratio of the Expenditure(as % of GDP) of 1971 in Italy to that in Kenya?
Give a very brief answer. 2.69. What is the ratio of the Expenditure(as % of GDP) of 1972 in Italy to that in Kenya?
Keep it short and to the point. 1.63. What is the ratio of the Expenditure(as % of GDP) in 1973 in Italy to that in Kenya?
Keep it short and to the point. 1.67. What is the ratio of the Expenditure(as % of GDP) in 1970 in Italy to that in Netherlands?
Your answer should be compact. 3.08. What is the ratio of the Expenditure(as % of GDP) of 1971 in Italy to that in Netherlands?
Offer a terse response. 2.38. What is the ratio of the Expenditure(as % of GDP) of 1972 in Italy to that in Netherlands?
Provide a short and direct response. 2.21. What is the ratio of the Expenditure(as % of GDP) of 1973 in Italy to that in Netherlands?
Your answer should be very brief. 1.61. What is the ratio of the Expenditure(as % of GDP) in 1970 in Kenya to that in Netherlands?
Provide a short and direct response. 1.28. What is the ratio of the Expenditure(as % of GDP) of 1971 in Kenya to that in Netherlands?
Offer a terse response. 0.88. What is the ratio of the Expenditure(as % of GDP) in 1972 in Kenya to that in Netherlands?
Provide a short and direct response. 1.36. What is the ratio of the Expenditure(as % of GDP) of 1973 in Kenya to that in Netherlands?
Make the answer very short. 0.97. What is the difference between the highest and the second highest Expenditure(as % of GDP) in 1970?
Provide a short and direct response. 0.35. What is the difference between the highest and the second highest Expenditure(as % of GDP) of 1971?
Keep it short and to the point. 1.41. What is the difference between the highest and the second highest Expenditure(as % of GDP) in 1972?
Provide a short and direct response. 1.44. What is the difference between the highest and the second highest Expenditure(as % of GDP) in 1973?
Provide a succinct answer. 0.9. What is the difference between the highest and the lowest Expenditure(as % of GDP) in 1970?
Provide a succinct answer. 1.34. What is the difference between the highest and the lowest Expenditure(as % of GDP) of 1971?
Keep it short and to the point. 2.23. What is the difference between the highest and the lowest Expenditure(as % of GDP) of 1972?
Provide a succinct answer. 2.39. What is the difference between the highest and the lowest Expenditure(as % of GDP) in 1973?
Ensure brevity in your answer.  1.64. 